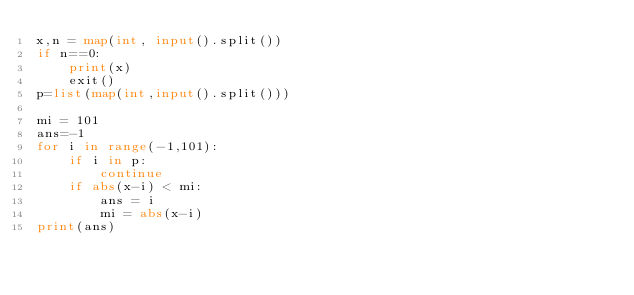<code> <loc_0><loc_0><loc_500><loc_500><_Python_>x,n = map(int, input().split())
if n==0:
    print(x)
    exit()
p=list(map(int,input().split()))

mi = 101
ans=-1
for i in range(-1,101):
    if i in p:
        continue
    if abs(x-i) < mi:
        ans = i
        mi = abs(x-i)
print(ans)</code> 